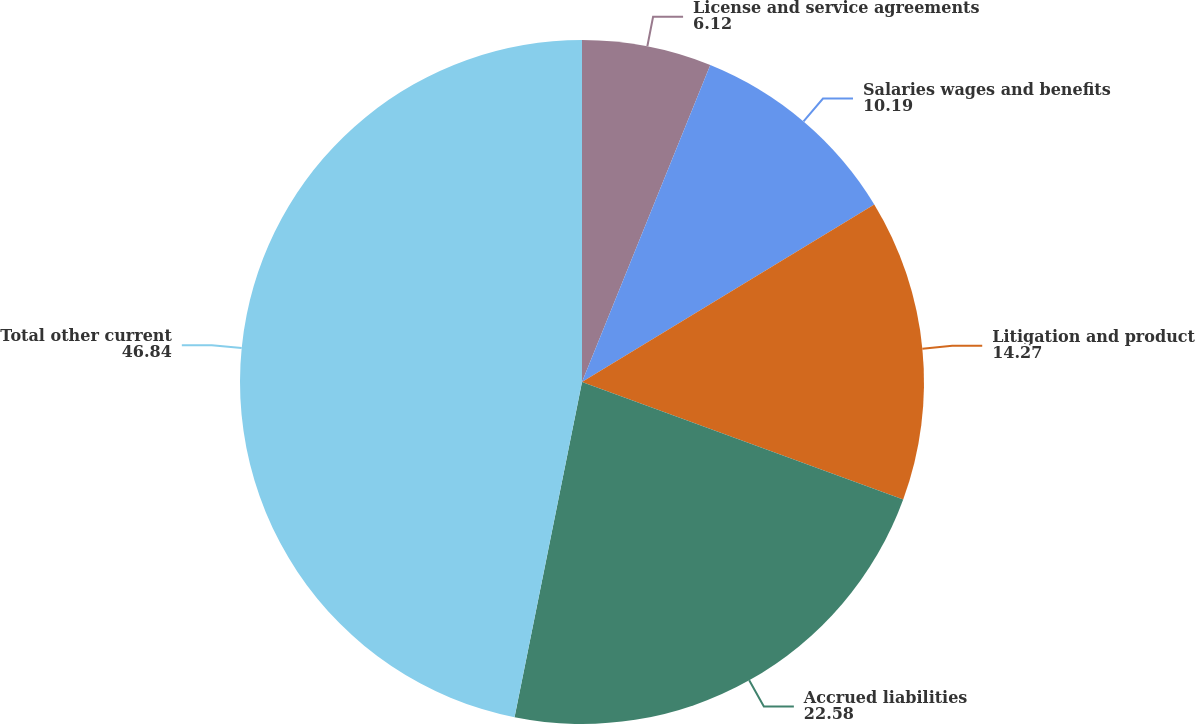Convert chart. <chart><loc_0><loc_0><loc_500><loc_500><pie_chart><fcel>License and service agreements<fcel>Salaries wages and benefits<fcel>Litigation and product<fcel>Accrued liabilities<fcel>Total other current<nl><fcel>6.12%<fcel>10.19%<fcel>14.27%<fcel>22.58%<fcel>46.84%<nl></chart> 